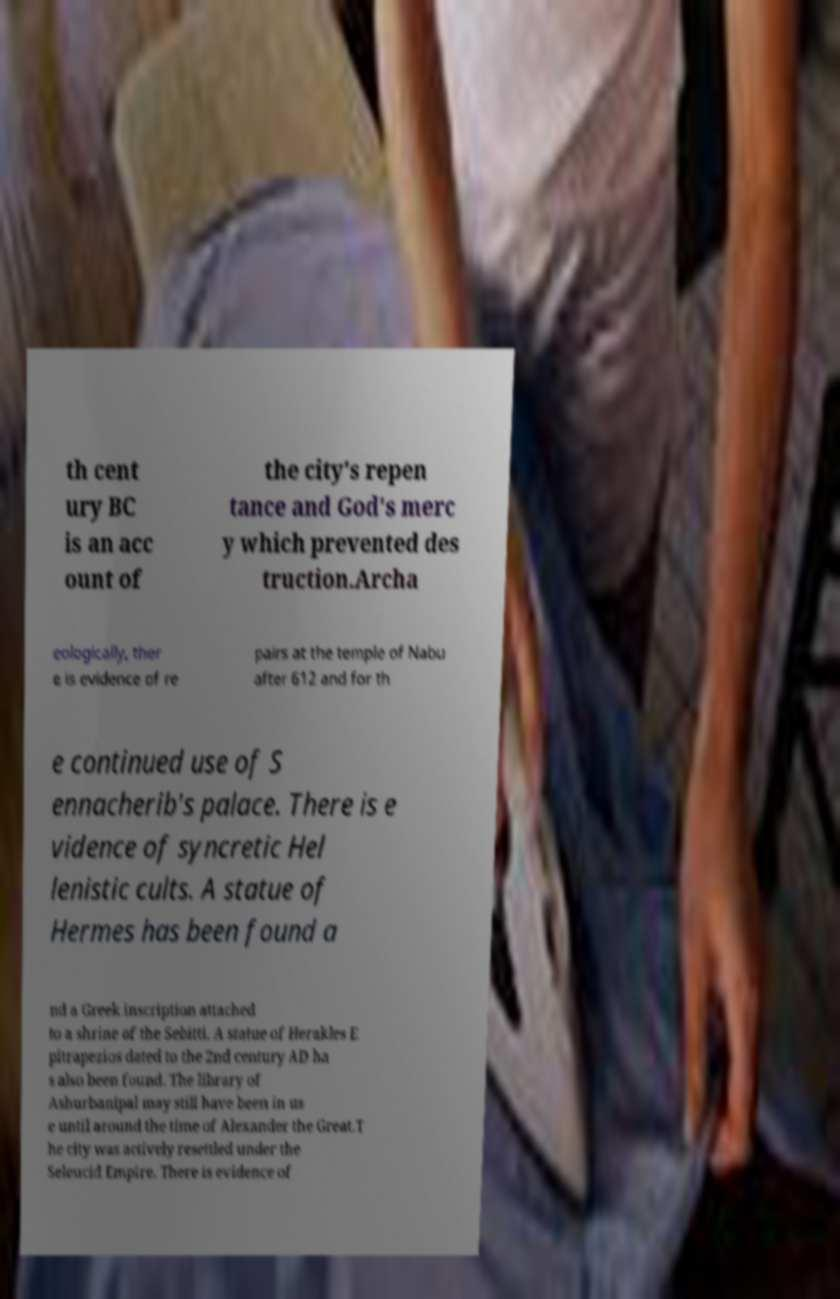Could you extract and type out the text from this image? th cent ury BC is an acc ount of the city's repen tance and God's merc y which prevented des truction.Archa eologically, ther e is evidence of re pairs at the temple of Nabu after 612 and for th e continued use of S ennacherib's palace. There is e vidence of syncretic Hel lenistic cults. A statue of Hermes has been found a nd a Greek inscription attached to a shrine of the Sebitti. A statue of Herakles E pitrapezios dated to the 2nd century AD ha s also been found. The library of Ashurbanipal may still have been in us e until around the time of Alexander the Great.T he city was actively resettled under the Seleucid Empire. There is evidence of 